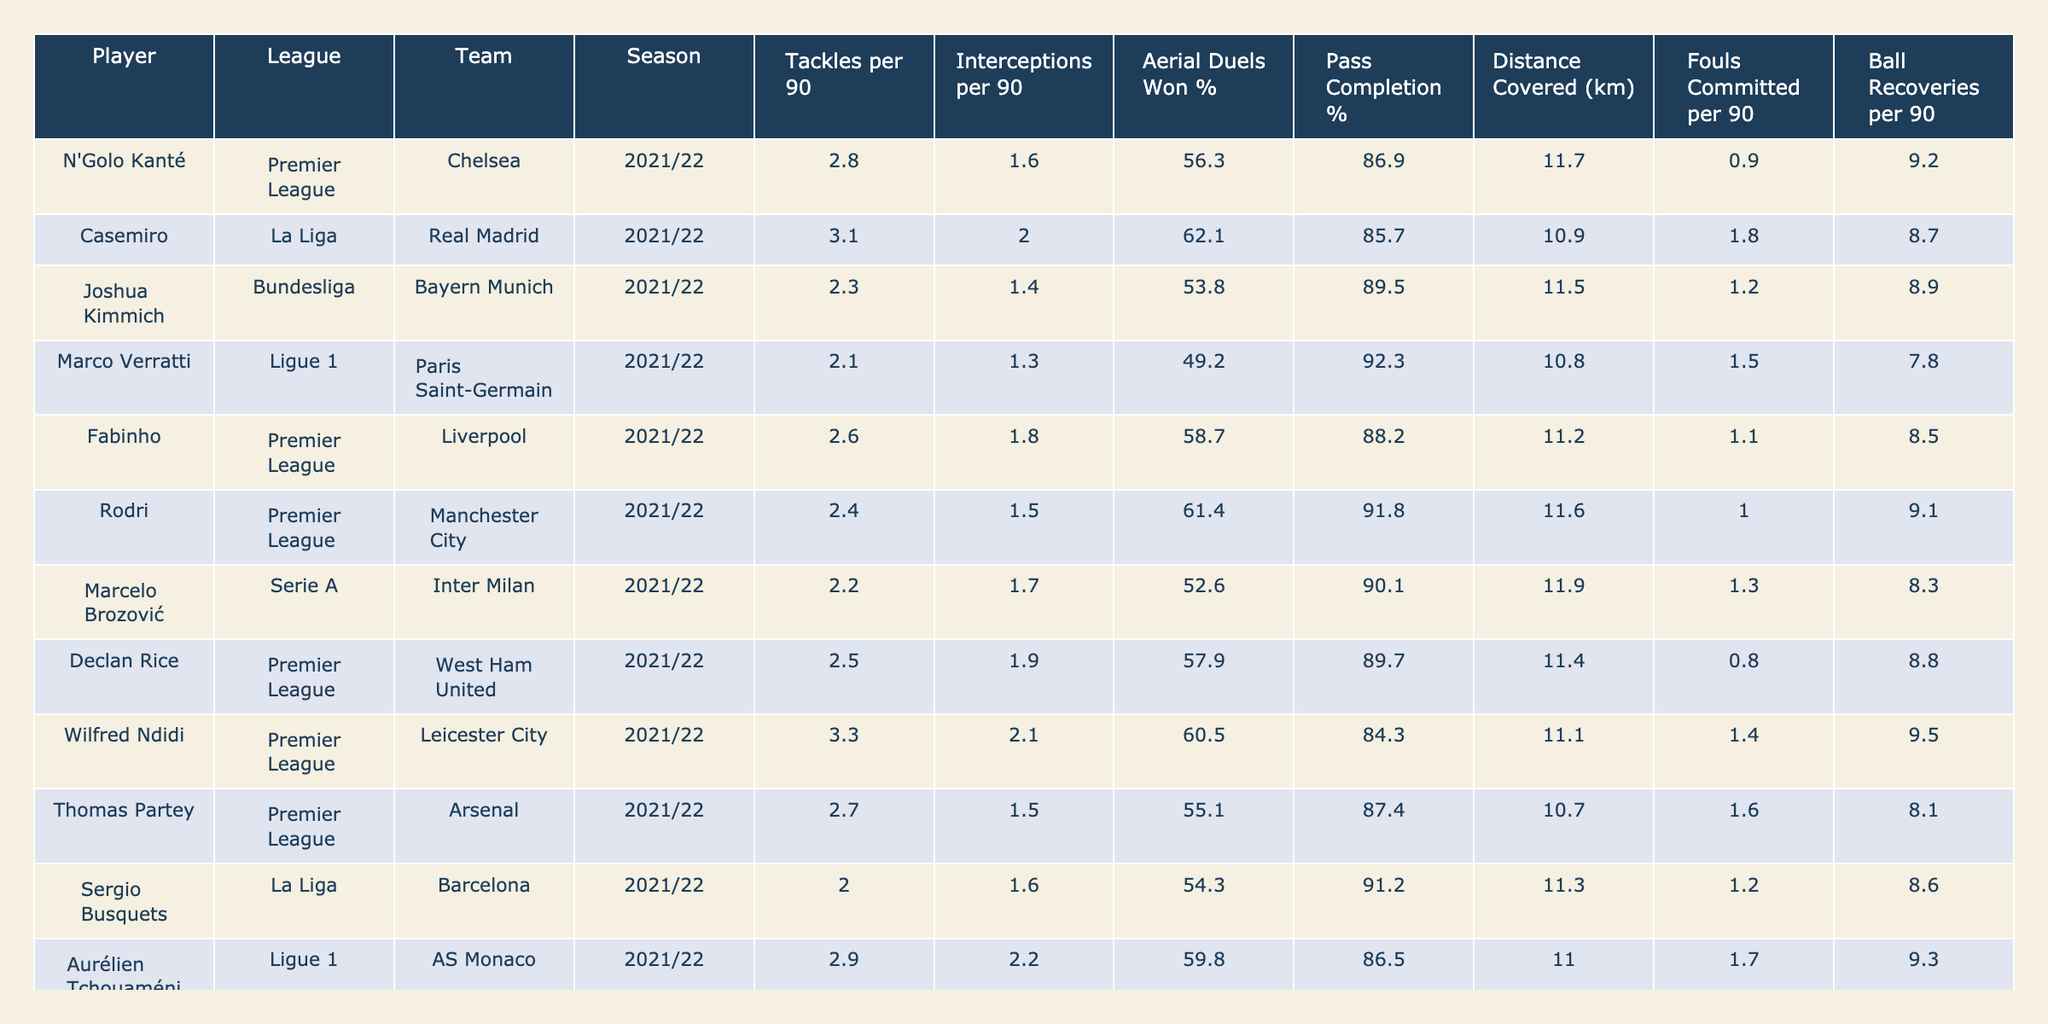What is the highest number of tackles per 90 minutes among the players listed? By looking at the "Tackles per 90" column, Casemiro has the highest value, which is 3.1.
Answer: 3.1 Which player has the best pass completion percentage? The "Pass Completion %" column shows Marco Verratti with a percentage of 92.3, which is the highest among all players.
Answer: 92.3 What is the average distance covered per game by the midfielders listed? To find the average, sum up the "Distance Covered (km)" values (11.7 + 10.9 + 11.5 + ... + 11.5) and divide by the total number of players (12). The sum is 136.1, and dividing by 12 gives an average of 11.35 km.
Answer: 11.35 Which player committed the most fouls per 90 minutes? The "Fouls Committed per 90" column indicates that Casemiro committed the most fouls with a value of 1.8.
Answer: 1.8 Is there a player with a pass completion percentage above 90%? By examining the "Pass Completion %" column, Marco Verratti and Jorginho have percentages above 90% (92.3 and 93.1, respectively). Therefore, the answer is yes.
Answer: Yes How many players had an aerial duels won percentage below 55%? Checking the "Aerial Duels Won %" column, we note that Marco Verratti (49.2) and Franck Kessié (56.9) are below 55%. Therefore, only Marco Verratti counts.
Answer: 1 Which league has the player with the highest average ball recoveries per 90 minutes? Looking at the "Ball Recoveries per 90" column, Wilfred Ndidi has the highest value of 9.5. A quick check shows he plays in the Premier League, confirming that the league is the Premier League.
Answer: Premier League What is the total number of interceptions made by all players per 90 minutes? To find the total interceptions, sum the values in the "Interceptions per 90" column (1.6 + 2.0 + 1.4 + ... + 1.7). The total is 18.2 interceptions.
Answer: 18.2 Which player has the highest number of tackles and what team do they play for? The player with the highest tackles per 90 is Casemiro with 3.1 tackles, and he plays for Real Madrid.
Answer: Casemiro, Real Madrid If you compare the average fouls committed per 90 minutes for Premier League players versus La Liga players, which one has a higher average? First, find the average for Premier League players (0.9 + 1.1 + 0.8 + 1.4 + 1.6 + 1.2) = 1.1. For La Liga players, the averages are (1.8 + 1.2) = 1.5. Comparing 1.1 (Premier League) to 1.5 (La Liga) shows that La Liga has a higher average.
Answer: La Liga 